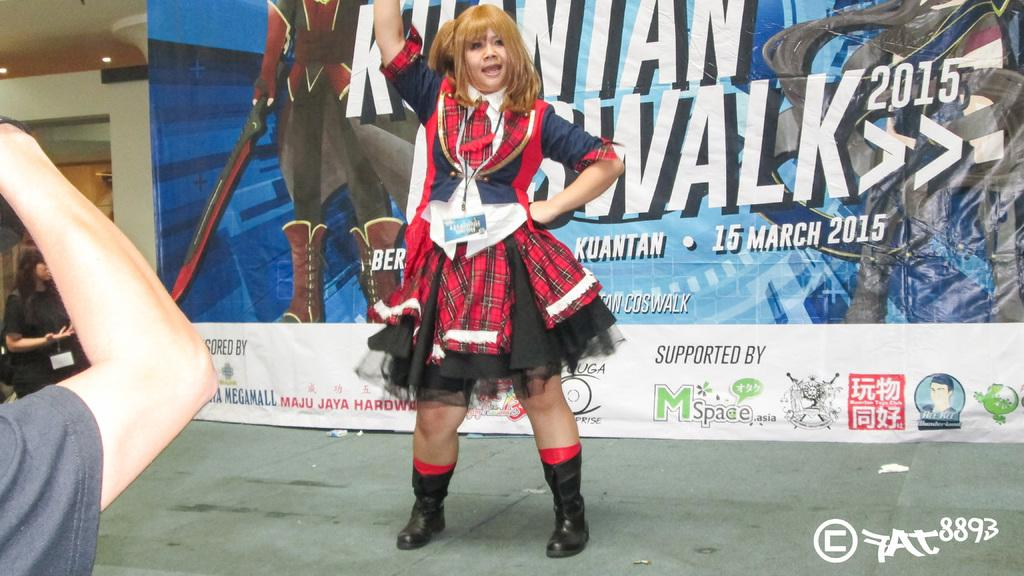Who is the main subject in the image? There is a lady in the center of the image. What is the lady wearing? The lady is wearing a black dress. What can be seen in the background of the image? There is a banner in the background of the image. Can you describe the person's hand at the left side of the image? There is a person's hand at the left side of the image. What type of skin condition is visible on the lady's face in the image? There is no indication of a skin condition on the lady's face in the image. What type of sail is visible in the image? There is no sail present in the image. 